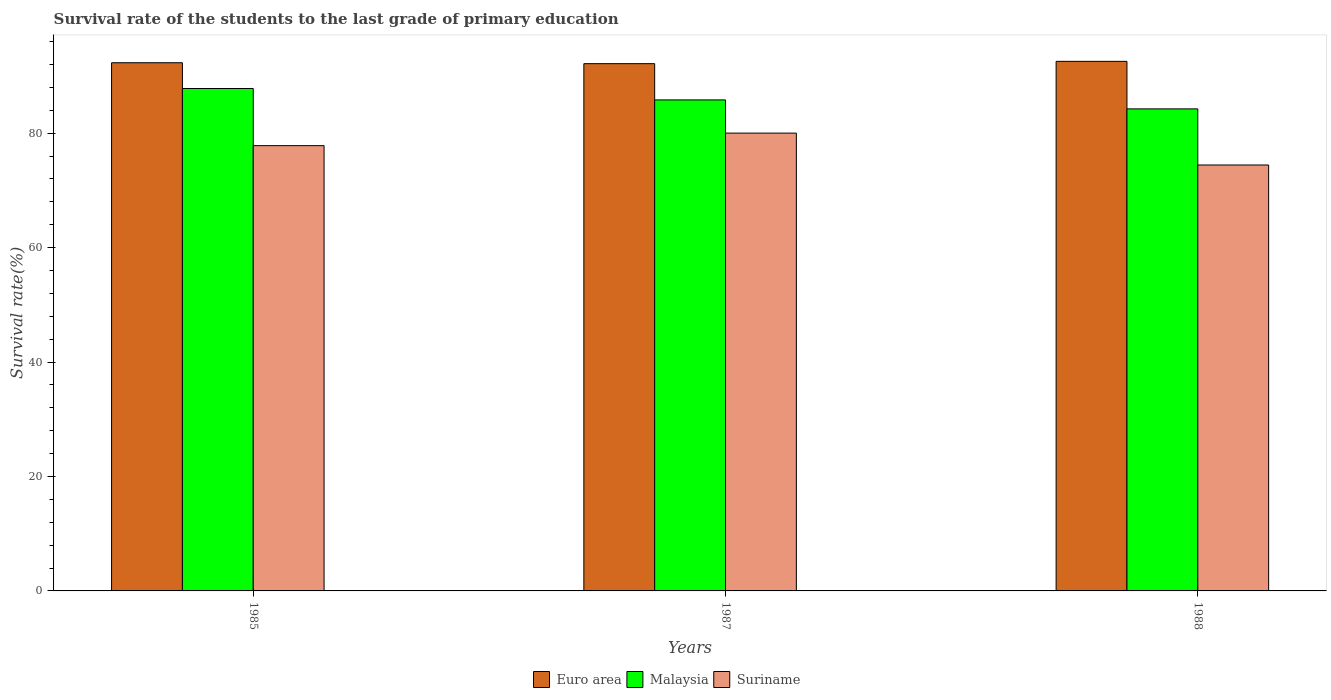Are the number of bars per tick equal to the number of legend labels?
Offer a very short reply. Yes. Are the number of bars on each tick of the X-axis equal?
Keep it short and to the point. Yes. How many bars are there on the 2nd tick from the right?
Give a very brief answer. 3. What is the label of the 2nd group of bars from the left?
Keep it short and to the point. 1987. In how many cases, is the number of bars for a given year not equal to the number of legend labels?
Give a very brief answer. 0. What is the survival rate of the students in Malaysia in 1985?
Your answer should be compact. 87.8. Across all years, what is the maximum survival rate of the students in Malaysia?
Provide a short and direct response. 87.8. Across all years, what is the minimum survival rate of the students in Euro area?
Your response must be concise. 92.15. In which year was the survival rate of the students in Euro area minimum?
Offer a very short reply. 1987. What is the total survival rate of the students in Euro area in the graph?
Ensure brevity in your answer.  277.01. What is the difference between the survival rate of the students in Euro area in 1985 and that in 1988?
Offer a terse response. -0.24. What is the difference between the survival rate of the students in Euro area in 1988 and the survival rate of the students in Malaysia in 1985?
Your response must be concise. 4.75. What is the average survival rate of the students in Euro area per year?
Your response must be concise. 92.34. In the year 1988, what is the difference between the survival rate of the students in Euro area and survival rate of the students in Suriname?
Ensure brevity in your answer.  18.11. What is the ratio of the survival rate of the students in Suriname in 1987 to that in 1988?
Make the answer very short. 1.07. What is the difference between the highest and the second highest survival rate of the students in Suriname?
Provide a short and direct response. 2.19. What is the difference between the highest and the lowest survival rate of the students in Malaysia?
Offer a terse response. 3.56. Is the sum of the survival rate of the students in Malaysia in 1985 and 1987 greater than the maximum survival rate of the students in Suriname across all years?
Give a very brief answer. Yes. What does the 3rd bar from the left in 1987 represents?
Your answer should be compact. Suriname. How many bars are there?
Your response must be concise. 9. Are all the bars in the graph horizontal?
Provide a short and direct response. No. Are the values on the major ticks of Y-axis written in scientific E-notation?
Offer a terse response. No. Does the graph contain any zero values?
Your answer should be compact. No. Where does the legend appear in the graph?
Offer a very short reply. Bottom center. How many legend labels are there?
Give a very brief answer. 3. What is the title of the graph?
Provide a short and direct response. Survival rate of the students to the last grade of primary education. What is the label or title of the Y-axis?
Make the answer very short. Survival rate(%). What is the Survival rate(%) in Euro area in 1985?
Your answer should be very brief. 92.31. What is the Survival rate(%) in Malaysia in 1985?
Provide a short and direct response. 87.8. What is the Survival rate(%) of Suriname in 1985?
Offer a very short reply. 77.82. What is the Survival rate(%) in Euro area in 1987?
Ensure brevity in your answer.  92.15. What is the Survival rate(%) in Malaysia in 1987?
Your response must be concise. 85.81. What is the Survival rate(%) in Suriname in 1987?
Offer a terse response. 80.01. What is the Survival rate(%) in Euro area in 1988?
Offer a terse response. 92.55. What is the Survival rate(%) of Malaysia in 1988?
Give a very brief answer. 84.24. What is the Survival rate(%) in Suriname in 1988?
Your answer should be compact. 74.44. Across all years, what is the maximum Survival rate(%) of Euro area?
Your answer should be compact. 92.55. Across all years, what is the maximum Survival rate(%) in Malaysia?
Your response must be concise. 87.8. Across all years, what is the maximum Survival rate(%) in Suriname?
Give a very brief answer. 80.01. Across all years, what is the minimum Survival rate(%) in Euro area?
Your answer should be compact. 92.15. Across all years, what is the minimum Survival rate(%) in Malaysia?
Provide a succinct answer. 84.24. Across all years, what is the minimum Survival rate(%) of Suriname?
Offer a very short reply. 74.44. What is the total Survival rate(%) of Euro area in the graph?
Your answer should be compact. 277.01. What is the total Survival rate(%) in Malaysia in the graph?
Offer a terse response. 257.86. What is the total Survival rate(%) of Suriname in the graph?
Provide a succinct answer. 232.27. What is the difference between the Survival rate(%) of Euro area in 1985 and that in 1987?
Ensure brevity in your answer.  0.16. What is the difference between the Survival rate(%) of Malaysia in 1985 and that in 1987?
Your answer should be very brief. 1.99. What is the difference between the Survival rate(%) of Suriname in 1985 and that in 1987?
Your answer should be compact. -2.19. What is the difference between the Survival rate(%) of Euro area in 1985 and that in 1988?
Your response must be concise. -0.24. What is the difference between the Survival rate(%) of Malaysia in 1985 and that in 1988?
Provide a succinct answer. 3.56. What is the difference between the Survival rate(%) in Suriname in 1985 and that in 1988?
Ensure brevity in your answer.  3.38. What is the difference between the Survival rate(%) of Euro area in 1987 and that in 1988?
Your response must be concise. -0.4. What is the difference between the Survival rate(%) of Malaysia in 1987 and that in 1988?
Provide a succinct answer. 1.57. What is the difference between the Survival rate(%) in Suriname in 1987 and that in 1988?
Give a very brief answer. 5.57. What is the difference between the Survival rate(%) of Euro area in 1985 and the Survival rate(%) of Malaysia in 1987?
Your answer should be compact. 6.49. What is the difference between the Survival rate(%) in Euro area in 1985 and the Survival rate(%) in Suriname in 1987?
Provide a short and direct response. 12.3. What is the difference between the Survival rate(%) of Malaysia in 1985 and the Survival rate(%) of Suriname in 1987?
Provide a short and direct response. 7.8. What is the difference between the Survival rate(%) in Euro area in 1985 and the Survival rate(%) in Malaysia in 1988?
Offer a terse response. 8.06. What is the difference between the Survival rate(%) of Euro area in 1985 and the Survival rate(%) of Suriname in 1988?
Provide a succinct answer. 17.87. What is the difference between the Survival rate(%) in Malaysia in 1985 and the Survival rate(%) in Suriname in 1988?
Provide a succinct answer. 13.37. What is the difference between the Survival rate(%) of Euro area in 1987 and the Survival rate(%) of Malaysia in 1988?
Offer a very short reply. 7.9. What is the difference between the Survival rate(%) of Euro area in 1987 and the Survival rate(%) of Suriname in 1988?
Keep it short and to the point. 17.71. What is the difference between the Survival rate(%) in Malaysia in 1987 and the Survival rate(%) in Suriname in 1988?
Provide a succinct answer. 11.38. What is the average Survival rate(%) in Euro area per year?
Offer a terse response. 92.34. What is the average Survival rate(%) of Malaysia per year?
Your answer should be very brief. 85.95. What is the average Survival rate(%) of Suriname per year?
Keep it short and to the point. 77.42. In the year 1985, what is the difference between the Survival rate(%) in Euro area and Survival rate(%) in Malaysia?
Your response must be concise. 4.5. In the year 1985, what is the difference between the Survival rate(%) of Euro area and Survival rate(%) of Suriname?
Offer a very short reply. 14.49. In the year 1985, what is the difference between the Survival rate(%) in Malaysia and Survival rate(%) in Suriname?
Make the answer very short. 9.99. In the year 1987, what is the difference between the Survival rate(%) of Euro area and Survival rate(%) of Malaysia?
Make the answer very short. 6.33. In the year 1987, what is the difference between the Survival rate(%) of Euro area and Survival rate(%) of Suriname?
Provide a short and direct response. 12.14. In the year 1987, what is the difference between the Survival rate(%) of Malaysia and Survival rate(%) of Suriname?
Your answer should be compact. 5.8. In the year 1988, what is the difference between the Survival rate(%) in Euro area and Survival rate(%) in Malaysia?
Your answer should be very brief. 8.31. In the year 1988, what is the difference between the Survival rate(%) in Euro area and Survival rate(%) in Suriname?
Give a very brief answer. 18.11. In the year 1988, what is the difference between the Survival rate(%) in Malaysia and Survival rate(%) in Suriname?
Your response must be concise. 9.81. What is the ratio of the Survival rate(%) of Euro area in 1985 to that in 1987?
Ensure brevity in your answer.  1. What is the ratio of the Survival rate(%) of Malaysia in 1985 to that in 1987?
Keep it short and to the point. 1.02. What is the ratio of the Survival rate(%) of Suriname in 1985 to that in 1987?
Ensure brevity in your answer.  0.97. What is the ratio of the Survival rate(%) in Euro area in 1985 to that in 1988?
Ensure brevity in your answer.  1. What is the ratio of the Survival rate(%) in Malaysia in 1985 to that in 1988?
Provide a succinct answer. 1.04. What is the ratio of the Survival rate(%) in Suriname in 1985 to that in 1988?
Provide a short and direct response. 1.05. What is the ratio of the Survival rate(%) of Malaysia in 1987 to that in 1988?
Your response must be concise. 1.02. What is the ratio of the Survival rate(%) in Suriname in 1987 to that in 1988?
Offer a very short reply. 1.07. What is the difference between the highest and the second highest Survival rate(%) of Euro area?
Give a very brief answer. 0.24. What is the difference between the highest and the second highest Survival rate(%) in Malaysia?
Offer a terse response. 1.99. What is the difference between the highest and the second highest Survival rate(%) in Suriname?
Your answer should be very brief. 2.19. What is the difference between the highest and the lowest Survival rate(%) of Euro area?
Offer a terse response. 0.4. What is the difference between the highest and the lowest Survival rate(%) of Malaysia?
Offer a very short reply. 3.56. What is the difference between the highest and the lowest Survival rate(%) of Suriname?
Offer a very short reply. 5.57. 